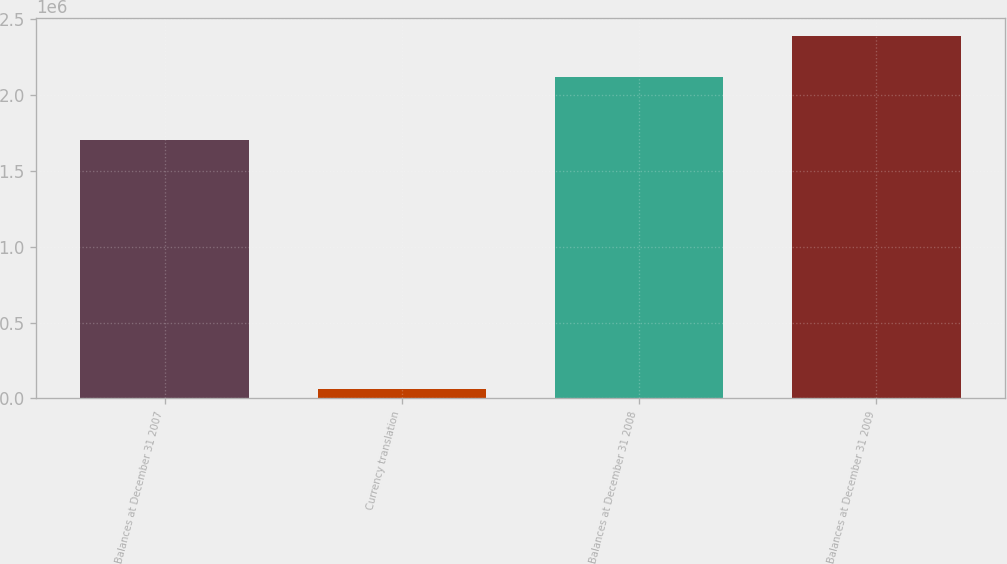Convert chart to OTSL. <chart><loc_0><loc_0><loc_500><loc_500><bar_chart><fcel>Balances at December 31 2007<fcel>Currency translation<fcel>Balances at December 31 2008<fcel>Balances at December 31 2009<nl><fcel>1.70608e+06<fcel>59797<fcel>2.11885e+06<fcel>2.38843e+06<nl></chart> 